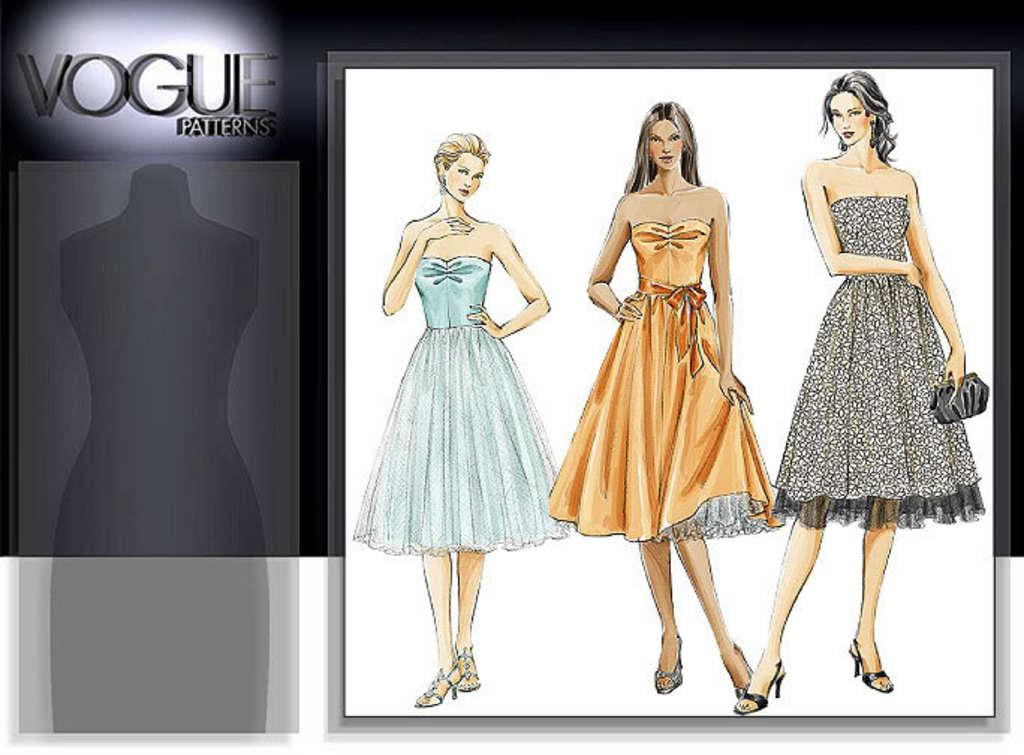What is depicted in the foreground of the poster? In the foreground of the poster, there is a sketch of three women wearing frocks. What are the women in the sketch doing? The women in the sketch are standing. What can be seen on the left side of the poster? On the left side of the poster, there is a shade of a mannequin. What is written on the poster? There is text on the top of the poster. What type of sock is the mannequin wearing in the image? There is no sock or mannequin present in the image; it features a sketch of three women wearing frocks and text on the top. What is the mannequin holding in the image? There is no mannequin or object present in the image. 